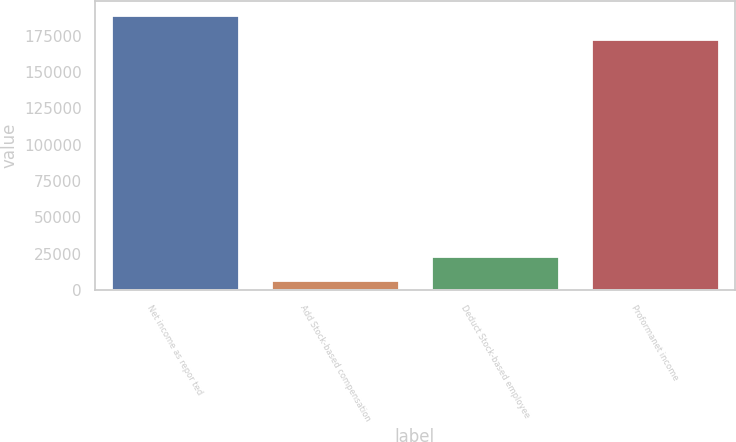Convert chart to OTSL. <chart><loc_0><loc_0><loc_500><loc_500><bar_chart><fcel>Net income as repor ted<fcel>Add Stock-based compensation<fcel>Deduct Stock-based employee<fcel>Proformanet income<nl><fcel>189397<fcel>6495<fcel>23151.2<fcel>172741<nl></chart> 